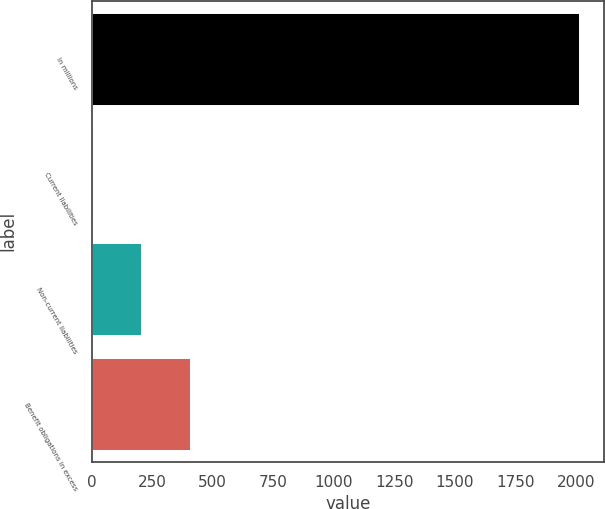<chart> <loc_0><loc_0><loc_500><loc_500><bar_chart><fcel>In millions<fcel>Current liabilities<fcel>Non-current liabilities<fcel>Benefit obligations in excess<nl><fcel>2014<fcel>4<fcel>205<fcel>406<nl></chart> 